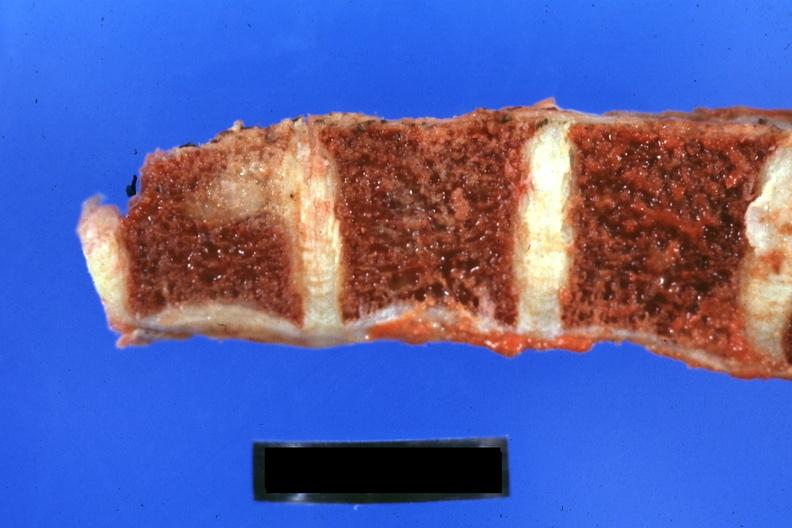what is present?
Answer the question using a single word or phrase. Joints 